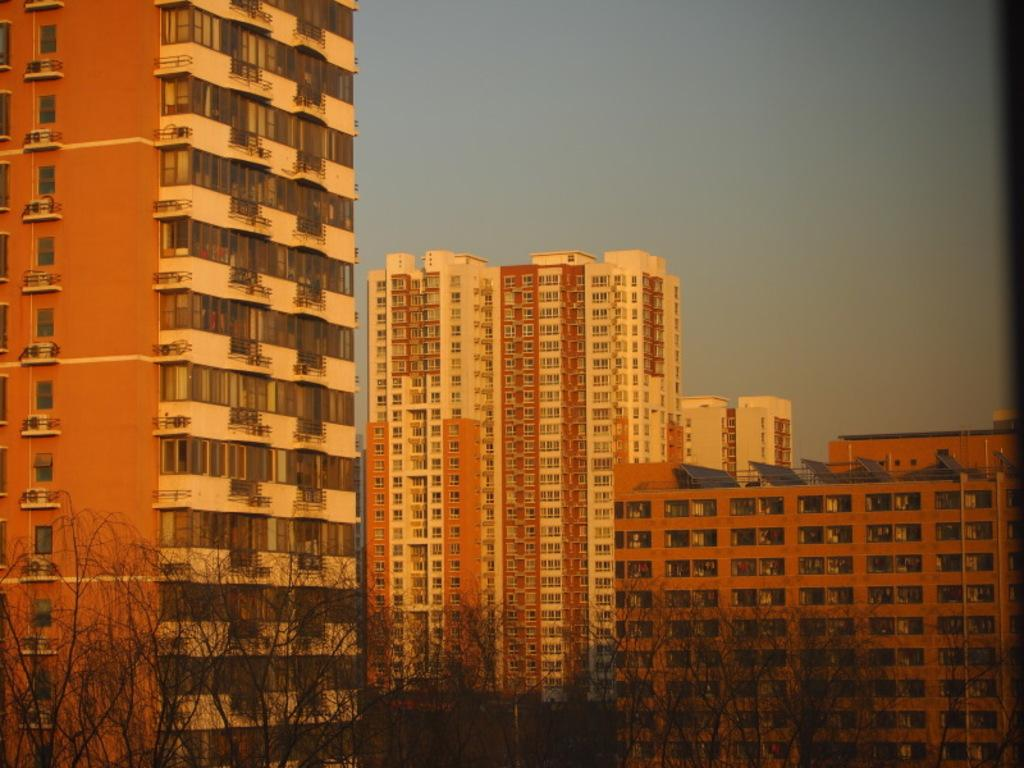What type of structures can be seen in the image? There are buildings in the image. What type of vegetation is present at the bottom of the image? There are trees at the bottom of the image. What part of the natural environment is visible in the image? The sky is visible in the background of the image. What type of toys can be seen in the image? There are no toys present in the image. What language is spoken by the people in the image? There are no people present in the image, so it is not possible to determine the language spoken. 